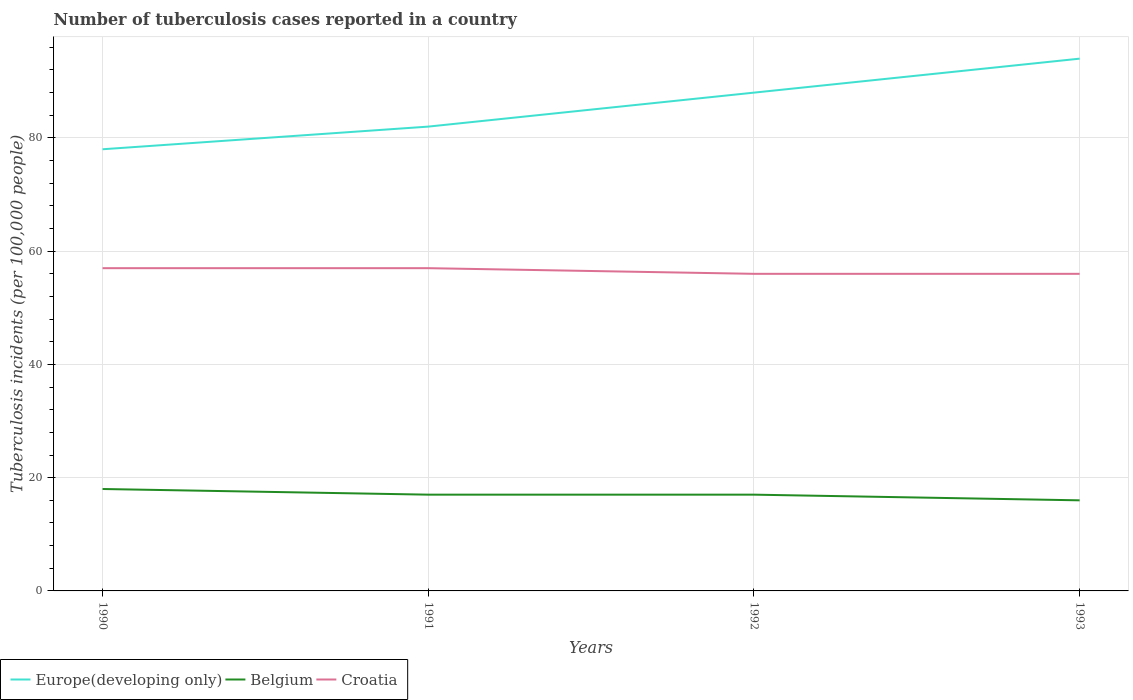How many different coloured lines are there?
Offer a very short reply. 3. Does the line corresponding to Europe(developing only) intersect with the line corresponding to Croatia?
Your answer should be compact. No. Is the number of lines equal to the number of legend labels?
Keep it short and to the point. Yes. Across all years, what is the maximum number of tuberculosis cases reported in in Belgium?
Provide a succinct answer. 16. What is the difference between the highest and the second highest number of tuberculosis cases reported in in Europe(developing only)?
Your answer should be very brief. 16. What is the difference between the highest and the lowest number of tuberculosis cases reported in in Belgium?
Your response must be concise. 1. Is the number of tuberculosis cases reported in in Belgium strictly greater than the number of tuberculosis cases reported in in Europe(developing only) over the years?
Your answer should be compact. Yes. How many lines are there?
Your answer should be very brief. 3. What is the difference between two consecutive major ticks on the Y-axis?
Make the answer very short. 20. Does the graph contain any zero values?
Your response must be concise. No. How many legend labels are there?
Offer a very short reply. 3. How are the legend labels stacked?
Provide a short and direct response. Horizontal. What is the title of the graph?
Give a very brief answer. Number of tuberculosis cases reported in a country. Does "Isle of Man" appear as one of the legend labels in the graph?
Give a very brief answer. No. What is the label or title of the X-axis?
Your answer should be compact. Years. What is the label or title of the Y-axis?
Provide a short and direct response. Tuberculosis incidents (per 100,0 people). What is the Tuberculosis incidents (per 100,000 people) of Croatia in 1990?
Make the answer very short. 57. What is the Tuberculosis incidents (per 100,000 people) in Croatia in 1991?
Your answer should be very brief. 57. What is the Tuberculosis incidents (per 100,000 people) of Croatia in 1992?
Offer a terse response. 56. What is the Tuberculosis incidents (per 100,000 people) of Europe(developing only) in 1993?
Offer a terse response. 94. What is the Tuberculosis incidents (per 100,000 people) of Belgium in 1993?
Provide a succinct answer. 16. What is the Tuberculosis incidents (per 100,000 people) in Croatia in 1993?
Your answer should be very brief. 56. Across all years, what is the maximum Tuberculosis incidents (per 100,000 people) of Europe(developing only)?
Offer a very short reply. 94. Across all years, what is the maximum Tuberculosis incidents (per 100,000 people) of Belgium?
Provide a succinct answer. 18. What is the total Tuberculosis incidents (per 100,000 people) in Europe(developing only) in the graph?
Your answer should be very brief. 342. What is the total Tuberculosis incidents (per 100,000 people) in Belgium in the graph?
Give a very brief answer. 68. What is the total Tuberculosis incidents (per 100,000 people) in Croatia in the graph?
Keep it short and to the point. 226. What is the difference between the Tuberculosis incidents (per 100,000 people) in Europe(developing only) in 1990 and that in 1991?
Ensure brevity in your answer.  -4. What is the difference between the Tuberculosis incidents (per 100,000 people) in Belgium in 1990 and that in 1991?
Your response must be concise. 1. What is the difference between the Tuberculosis incidents (per 100,000 people) in Croatia in 1990 and that in 1991?
Provide a succinct answer. 0. What is the difference between the Tuberculosis incidents (per 100,000 people) of Belgium in 1990 and that in 1992?
Provide a succinct answer. 1. What is the difference between the Tuberculosis incidents (per 100,000 people) of Europe(developing only) in 1990 and that in 1993?
Make the answer very short. -16. What is the difference between the Tuberculosis incidents (per 100,000 people) in Belgium in 1991 and that in 1993?
Your answer should be compact. 1. What is the difference between the Tuberculosis incidents (per 100,000 people) in Europe(developing only) in 1992 and that in 1993?
Your response must be concise. -6. What is the difference between the Tuberculosis incidents (per 100,000 people) in Belgium in 1992 and that in 1993?
Your response must be concise. 1. What is the difference between the Tuberculosis incidents (per 100,000 people) of Croatia in 1992 and that in 1993?
Your response must be concise. 0. What is the difference between the Tuberculosis incidents (per 100,000 people) of Europe(developing only) in 1990 and the Tuberculosis incidents (per 100,000 people) of Belgium in 1991?
Offer a terse response. 61. What is the difference between the Tuberculosis incidents (per 100,000 people) of Belgium in 1990 and the Tuberculosis incidents (per 100,000 people) of Croatia in 1991?
Offer a terse response. -39. What is the difference between the Tuberculosis incidents (per 100,000 people) of Europe(developing only) in 1990 and the Tuberculosis incidents (per 100,000 people) of Croatia in 1992?
Your answer should be compact. 22. What is the difference between the Tuberculosis incidents (per 100,000 people) in Belgium in 1990 and the Tuberculosis incidents (per 100,000 people) in Croatia in 1992?
Your response must be concise. -38. What is the difference between the Tuberculosis incidents (per 100,000 people) in Europe(developing only) in 1990 and the Tuberculosis incidents (per 100,000 people) in Belgium in 1993?
Your answer should be very brief. 62. What is the difference between the Tuberculosis incidents (per 100,000 people) of Europe(developing only) in 1990 and the Tuberculosis incidents (per 100,000 people) of Croatia in 1993?
Your answer should be very brief. 22. What is the difference between the Tuberculosis incidents (per 100,000 people) of Belgium in 1990 and the Tuberculosis incidents (per 100,000 people) of Croatia in 1993?
Offer a very short reply. -38. What is the difference between the Tuberculosis incidents (per 100,000 people) in Europe(developing only) in 1991 and the Tuberculosis incidents (per 100,000 people) in Croatia in 1992?
Offer a terse response. 26. What is the difference between the Tuberculosis incidents (per 100,000 people) of Belgium in 1991 and the Tuberculosis incidents (per 100,000 people) of Croatia in 1992?
Ensure brevity in your answer.  -39. What is the difference between the Tuberculosis incidents (per 100,000 people) in Europe(developing only) in 1991 and the Tuberculosis incidents (per 100,000 people) in Belgium in 1993?
Ensure brevity in your answer.  66. What is the difference between the Tuberculosis incidents (per 100,000 people) of Europe(developing only) in 1991 and the Tuberculosis incidents (per 100,000 people) of Croatia in 1993?
Provide a short and direct response. 26. What is the difference between the Tuberculosis incidents (per 100,000 people) in Belgium in 1991 and the Tuberculosis incidents (per 100,000 people) in Croatia in 1993?
Offer a very short reply. -39. What is the difference between the Tuberculosis incidents (per 100,000 people) in Europe(developing only) in 1992 and the Tuberculosis incidents (per 100,000 people) in Belgium in 1993?
Your response must be concise. 72. What is the difference between the Tuberculosis incidents (per 100,000 people) in Europe(developing only) in 1992 and the Tuberculosis incidents (per 100,000 people) in Croatia in 1993?
Your response must be concise. 32. What is the difference between the Tuberculosis incidents (per 100,000 people) in Belgium in 1992 and the Tuberculosis incidents (per 100,000 people) in Croatia in 1993?
Give a very brief answer. -39. What is the average Tuberculosis incidents (per 100,000 people) of Europe(developing only) per year?
Your response must be concise. 85.5. What is the average Tuberculosis incidents (per 100,000 people) in Croatia per year?
Provide a short and direct response. 56.5. In the year 1990, what is the difference between the Tuberculosis incidents (per 100,000 people) of Belgium and Tuberculosis incidents (per 100,000 people) of Croatia?
Keep it short and to the point. -39. In the year 1992, what is the difference between the Tuberculosis incidents (per 100,000 people) of Europe(developing only) and Tuberculosis incidents (per 100,000 people) of Belgium?
Your response must be concise. 71. In the year 1992, what is the difference between the Tuberculosis incidents (per 100,000 people) in Belgium and Tuberculosis incidents (per 100,000 people) in Croatia?
Offer a terse response. -39. In the year 1993, what is the difference between the Tuberculosis incidents (per 100,000 people) of Europe(developing only) and Tuberculosis incidents (per 100,000 people) of Belgium?
Offer a very short reply. 78. What is the ratio of the Tuberculosis incidents (per 100,000 people) in Europe(developing only) in 1990 to that in 1991?
Ensure brevity in your answer.  0.95. What is the ratio of the Tuberculosis incidents (per 100,000 people) of Belgium in 1990 to that in 1991?
Your answer should be compact. 1.06. What is the ratio of the Tuberculosis incidents (per 100,000 people) in Croatia in 1990 to that in 1991?
Your answer should be compact. 1. What is the ratio of the Tuberculosis incidents (per 100,000 people) in Europe(developing only) in 1990 to that in 1992?
Give a very brief answer. 0.89. What is the ratio of the Tuberculosis incidents (per 100,000 people) in Belgium in 1990 to that in 1992?
Make the answer very short. 1.06. What is the ratio of the Tuberculosis incidents (per 100,000 people) of Croatia in 1990 to that in 1992?
Give a very brief answer. 1.02. What is the ratio of the Tuberculosis incidents (per 100,000 people) of Europe(developing only) in 1990 to that in 1993?
Ensure brevity in your answer.  0.83. What is the ratio of the Tuberculosis incidents (per 100,000 people) of Croatia in 1990 to that in 1993?
Give a very brief answer. 1.02. What is the ratio of the Tuberculosis incidents (per 100,000 people) of Europe(developing only) in 1991 to that in 1992?
Offer a very short reply. 0.93. What is the ratio of the Tuberculosis incidents (per 100,000 people) of Belgium in 1991 to that in 1992?
Ensure brevity in your answer.  1. What is the ratio of the Tuberculosis incidents (per 100,000 people) in Croatia in 1991 to that in 1992?
Offer a very short reply. 1.02. What is the ratio of the Tuberculosis incidents (per 100,000 people) of Europe(developing only) in 1991 to that in 1993?
Your answer should be compact. 0.87. What is the ratio of the Tuberculosis incidents (per 100,000 people) in Belgium in 1991 to that in 1993?
Your answer should be compact. 1.06. What is the ratio of the Tuberculosis incidents (per 100,000 people) of Croatia in 1991 to that in 1993?
Your answer should be very brief. 1.02. What is the ratio of the Tuberculosis incidents (per 100,000 people) of Europe(developing only) in 1992 to that in 1993?
Provide a succinct answer. 0.94. What is the ratio of the Tuberculosis incidents (per 100,000 people) of Belgium in 1992 to that in 1993?
Offer a terse response. 1.06. What is the difference between the highest and the lowest Tuberculosis incidents (per 100,000 people) in Europe(developing only)?
Provide a succinct answer. 16. What is the difference between the highest and the lowest Tuberculosis incidents (per 100,000 people) in Belgium?
Offer a terse response. 2. 